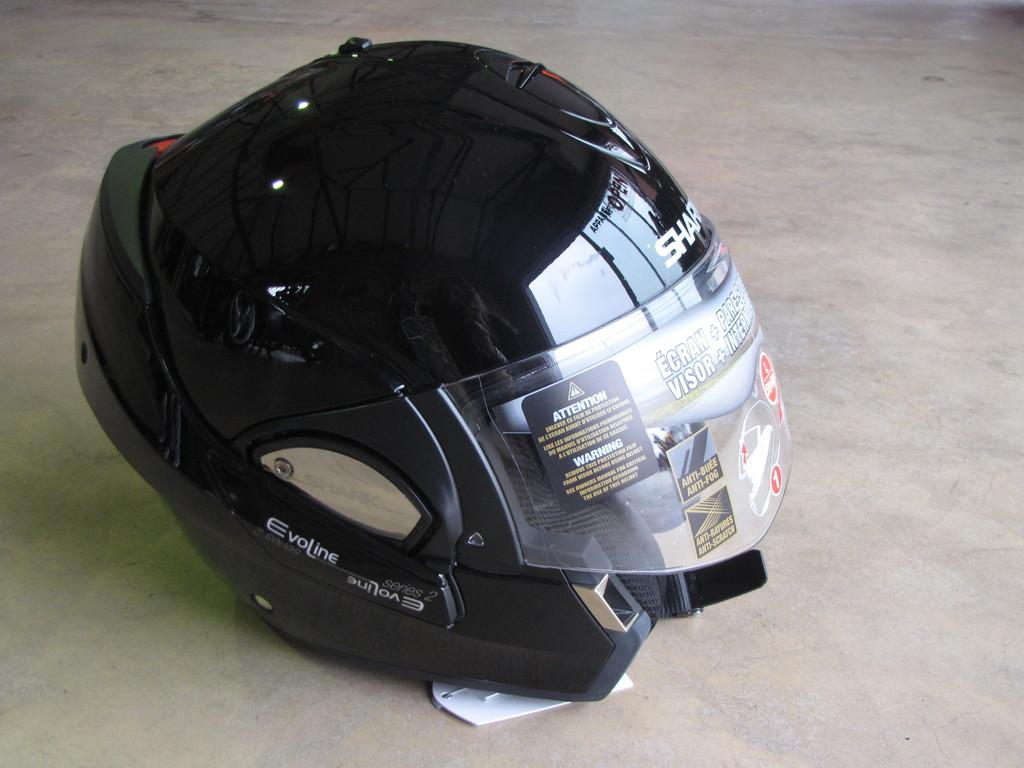What object can be seen on the floor in the image? There is a helmet on the floor in the image. What direction are the cars moving in the image? There are no cars present in the image; it only features a helmet on the floor. What type of air is visible in the image? There is no specific type of air visible in the image, as air is not a tangible object that can be seen. 